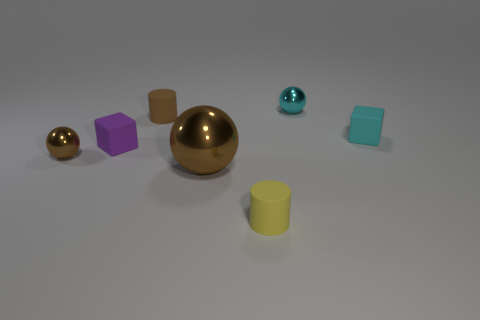Add 2 tiny rubber cylinders. How many objects exist? 9 Subtract all cubes. How many objects are left? 5 Add 4 cyan metallic things. How many cyan metallic things exist? 5 Subtract 1 cyan blocks. How many objects are left? 6 Subtract all tiny brown shiny spheres. Subtract all shiny things. How many objects are left? 3 Add 6 purple rubber cubes. How many purple rubber cubes are left? 7 